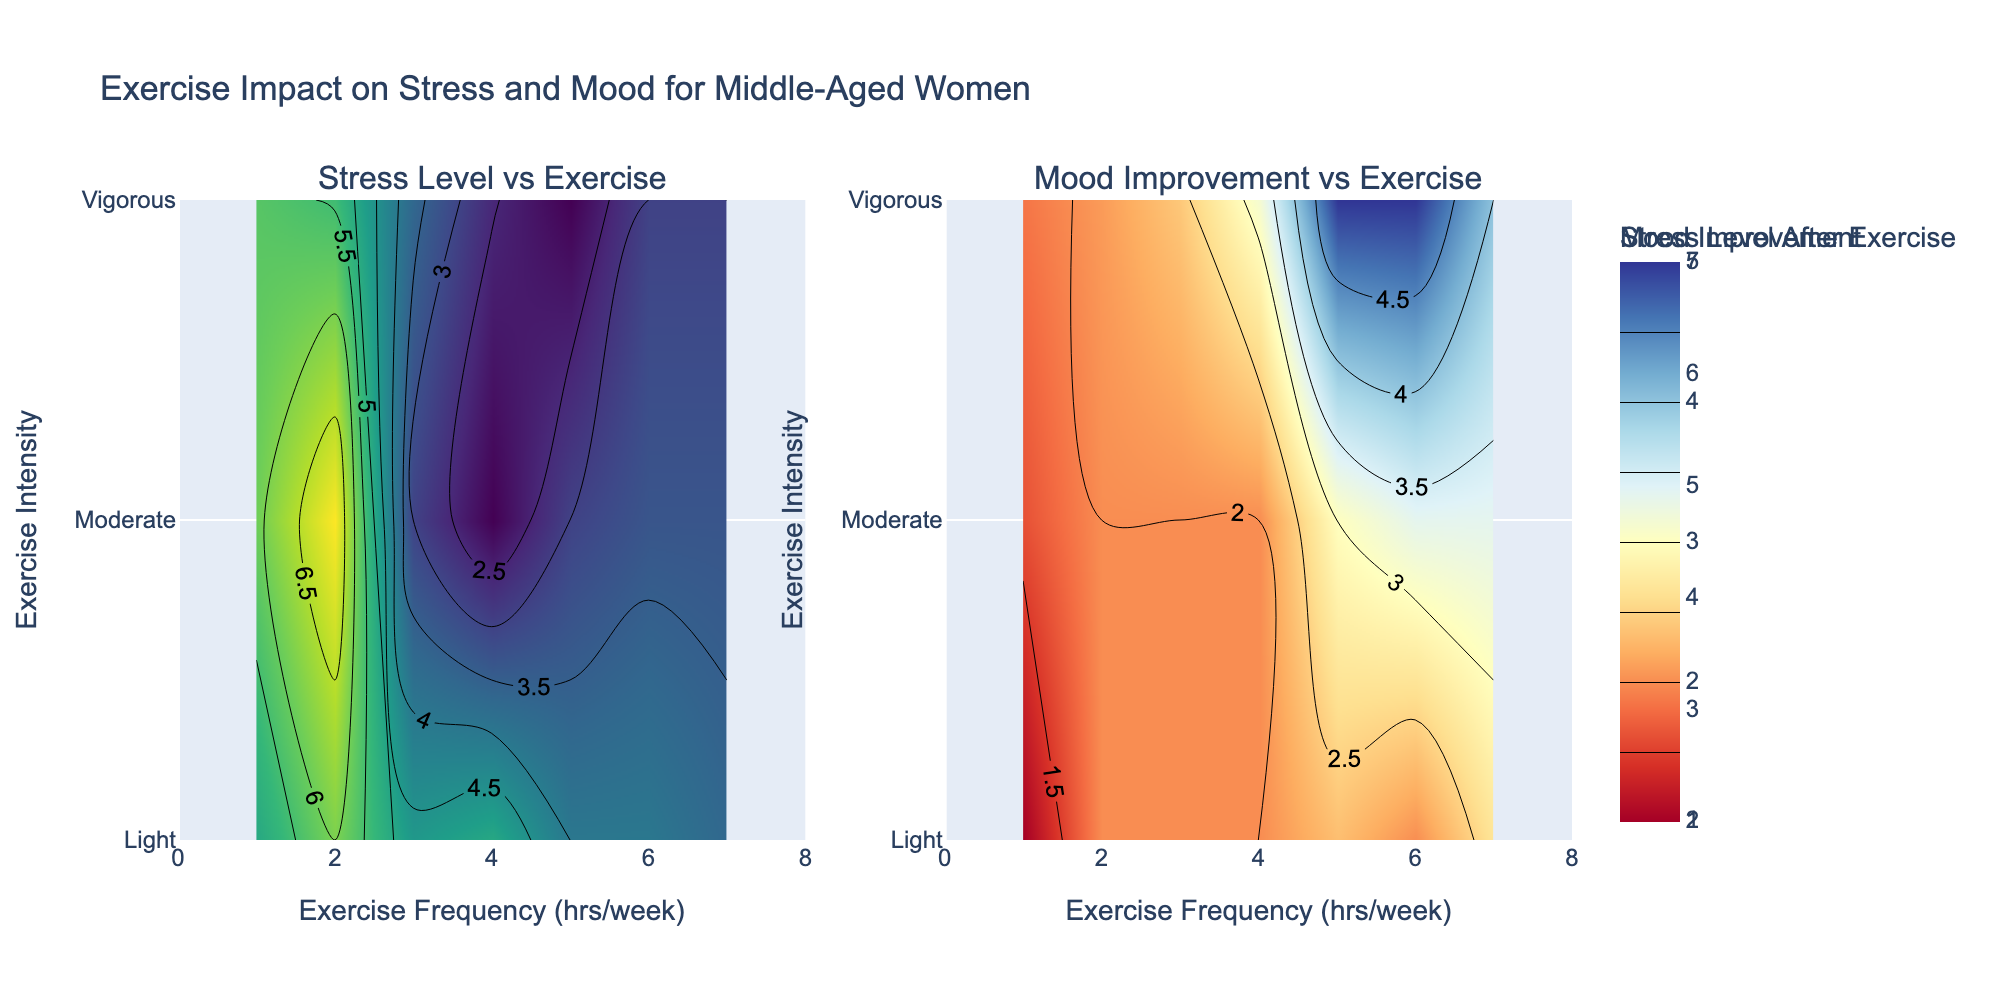What's the title of the figure? The title of the figure is located at the top and summarizes the subject matter of the visualization.
Answer: Exercise Impact on Stress and Mood for Middle-Aged Women What are the axis labels for the plots? The horizontal axis in both plots is labeled 'Exercise Frequency (hrs/week)', and the vertical axis is labeled 'Exercise Intensity' with values 'Light', 'Moderate', and 'Vigorous'.
Answer: Exercise Frequency (hrs/week) and Exercise Intensity What is the color scale used for the Stress Level After Exercise plot? The Stress Level After Exercise plot uses the 'Viridis' color scale, indicated by the gradient from dark blue to yellow.
Answer: Viridis How does the stress level after exercise change with different exercise intensities for someone who exercises 5 hours per week? One needs to look at the contour lines and color gradients corresponding to 5 hours per week on the horizontal axis and compare the stress levels for 'Light', 'Moderate', and 'Vigorous' intensities. For 'Light' intensity, it's higher and decreases as the intensity increases to 'Vigorous'.
Answer: Stress level decreases with increasing intensity Which exercise intensity shows the highest mood improvement for someone who exercises 6 hours per week? By observing the contour lines and color gradients for mood improvement on the right plot at 6 hours per week, one can see the highest values for 'Vigorous' intensity (the most positive gradient).
Answer: Vigorous On average, how does exercise frequency affect stress levels? To determine the average effect of exercise frequency on stress levels, look at the overall trends on the left plot; as exercise frequency increases, the stress levels generally show a decreasing trend, indicated by cooler colors.
Answer: Generally decreases What exercise intensity results in the lowest stress level for any exercise frequency? By observing the contour plot for Stress Level After Exercise, the 'Vigorous' intensity often shows the lowest stress levels (coolest colors such as dark blue or green).
Answer: Vigorous Is there any exercise frequency range where mood improvement is negative? By examining the range and colors in the Mood Improvement contour plot, we can check if there are any areas with negative gradients (cooler colors in 'RdYlBu' such as blue). There are no frequencies with negative mood improvement.
Answer: No, all improvements are positive Which hours per week range shows the maximum variation in stress levels after exercise for all intensity levels? Check the left plot for the widest range of color gradients corresponding to one range of exercise frequency. The range 2-4 hours per week shows a significant variation in stress levels for all intensity levels.
Answer: 2-4 hours per week How does mood improvement compare between 'Moderate' and 'Vigorous' exercise intensities for a frequency of 3 hours per week? Using the right plot, we can compare the contour colors for 'Moderate' and 'Vigorous' intensities with an exercise frequency of 3 hours per week. 'Vigorous' intensity shows more positive mood improvement (warmer colors) than 'Moderate'.
Answer: Vigorous shows higher mood improvement 